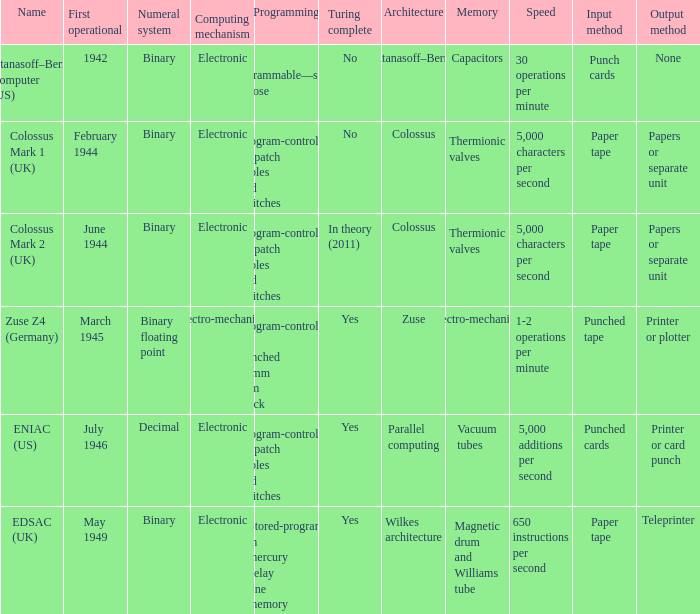What's the first operational with programming being not programmable—single purpose 1942.0. 